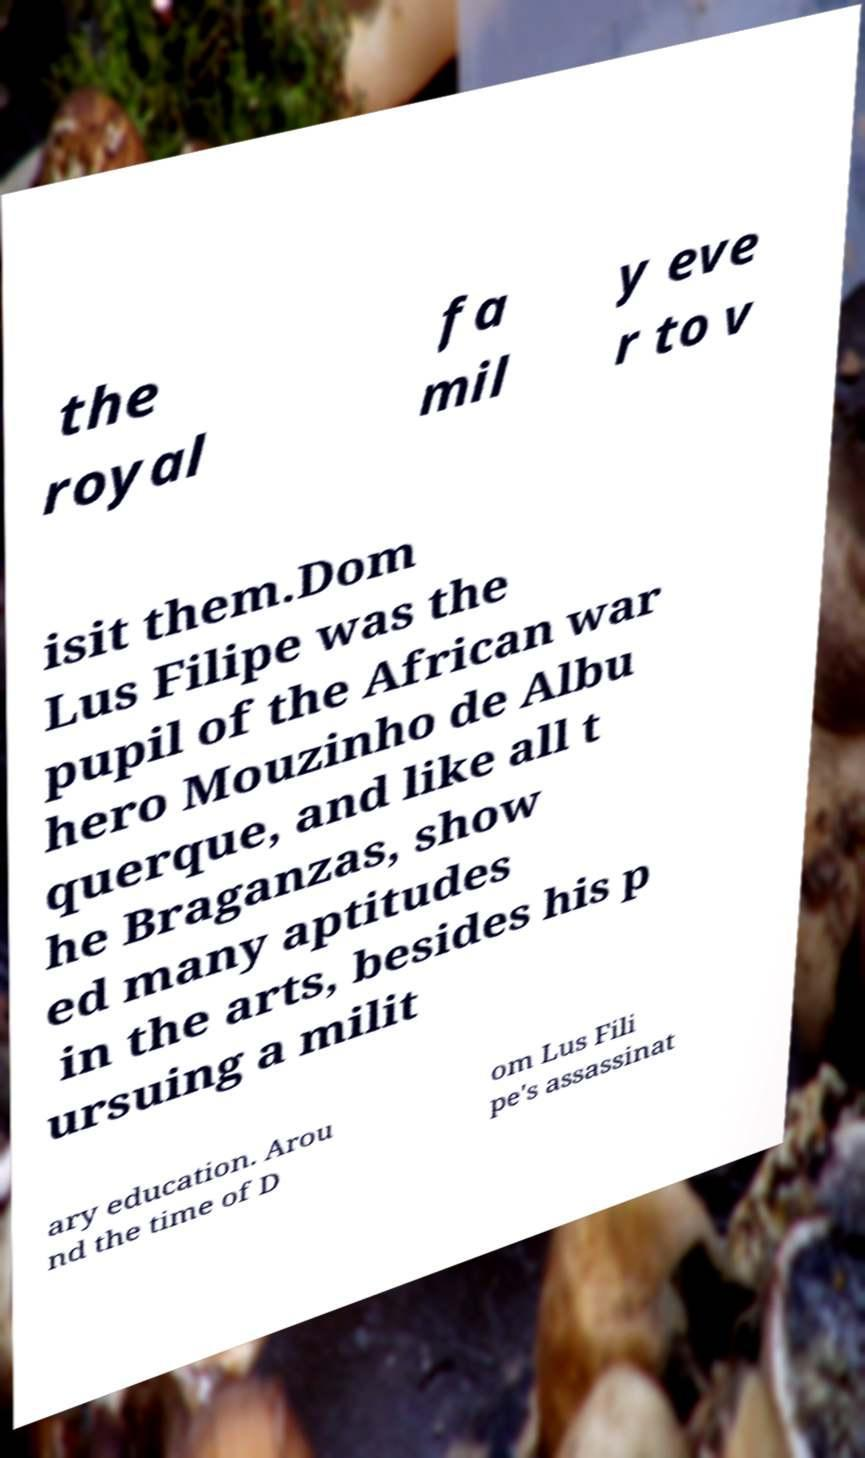I need the written content from this picture converted into text. Can you do that? the royal fa mil y eve r to v isit them.Dom Lus Filipe was the pupil of the African war hero Mouzinho de Albu querque, and like all t he Braganzas, show ed many aptitudes in the arts, besides his p ursuing a milit ary education. Arou nd the time of D om Lus Fili pe's assassinat 